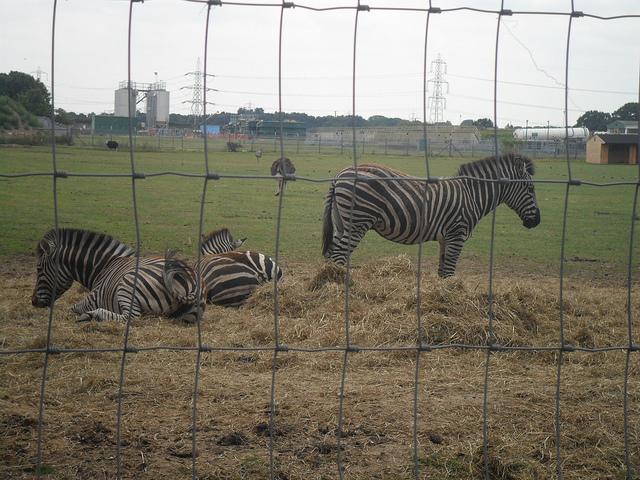How many animals are standing?
Concise answer only. 1. Is there a fence here?
Concise answer only. Yes. What is covering the ground?
Short answer required. Hay. How many animals?
Give a very brief answer. 4. 